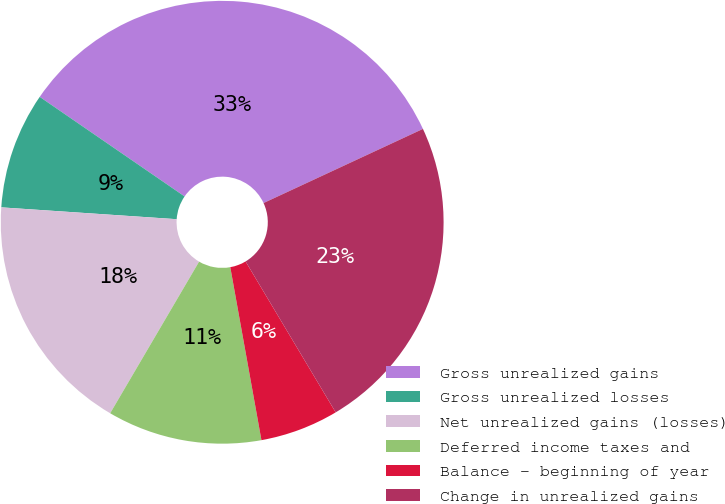<chart> <loc_0><loc_0><loc_500><loc_500><pie_chart><fcel>Gross unrealized gains<fcel>Gross unrealized losses<fcel>Net unrealized gains (losses)<fcel>Deferred income taxes and<fcel>Balance - beginning of year<fcel>Change in unrealized gains<nl><fcel>33.49%<fcel>8.51%<fcel>17.63%<fcel>11.28%<fcel>5.73%<fcel>23.36%<nl></chart> 